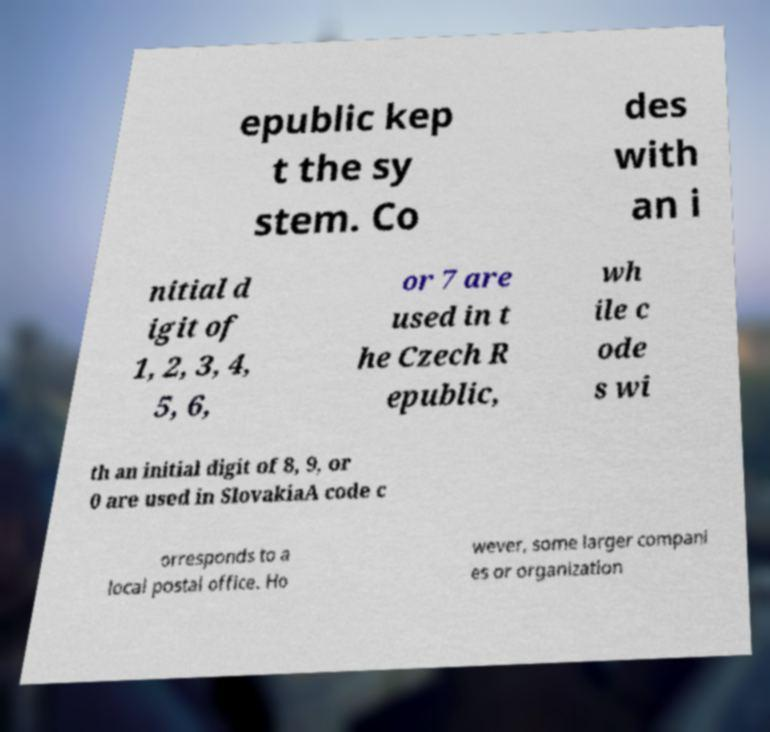Please identify and transcribe the text found in this image. epublic kep t the sy stem. Co des with an i nitial d igit of 1, 2, 3, 4, 5, 6, or 7 are used in t he Czech R epublic, wh ile c ode s wi th an initial digit of 8, 9, or 0 are used in SlovakiaA code c orresponds to a local postal office. Ho wever, some larger compani es or organization 